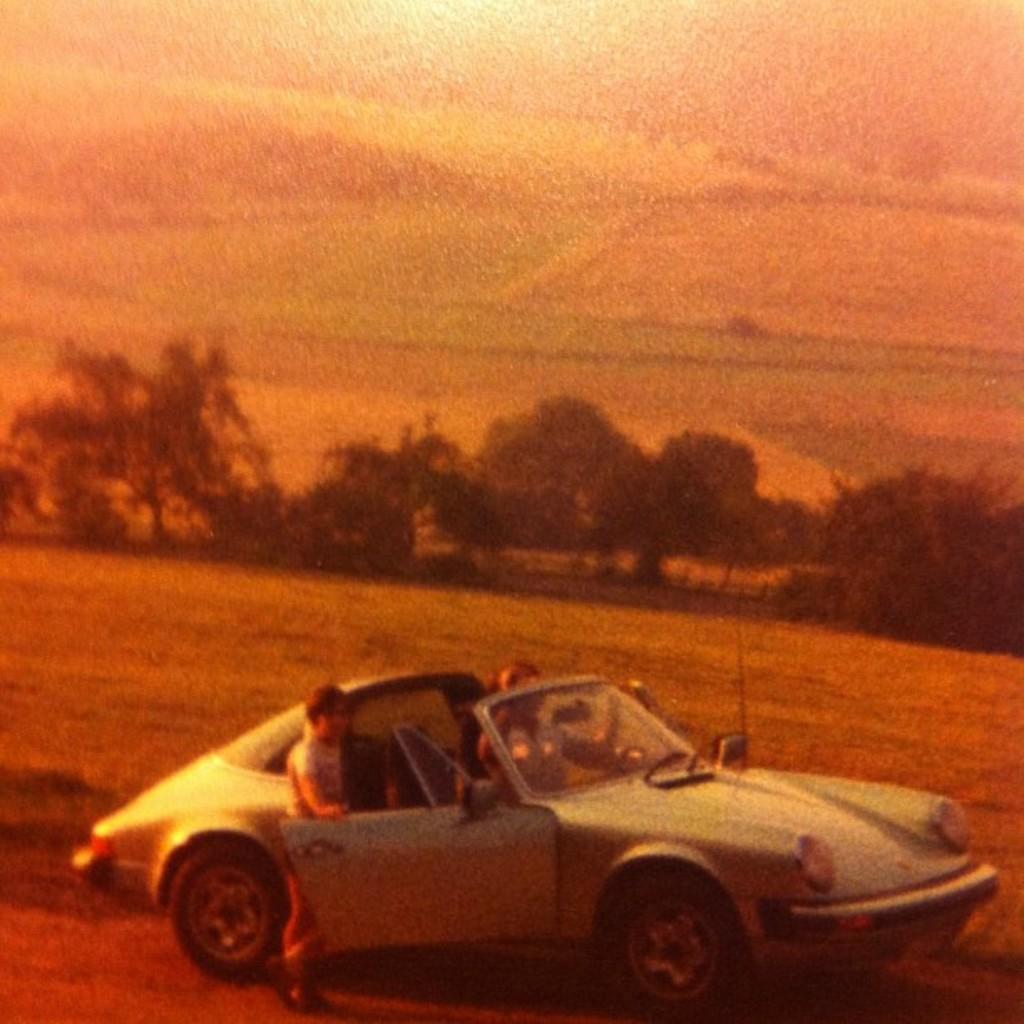Could you give a brief overview of what you see in this image? This picture is clicked outside. In the foreground we can see the two people and we can see a car parked on the ground. In the background we can see the sky, trees and some other items. 